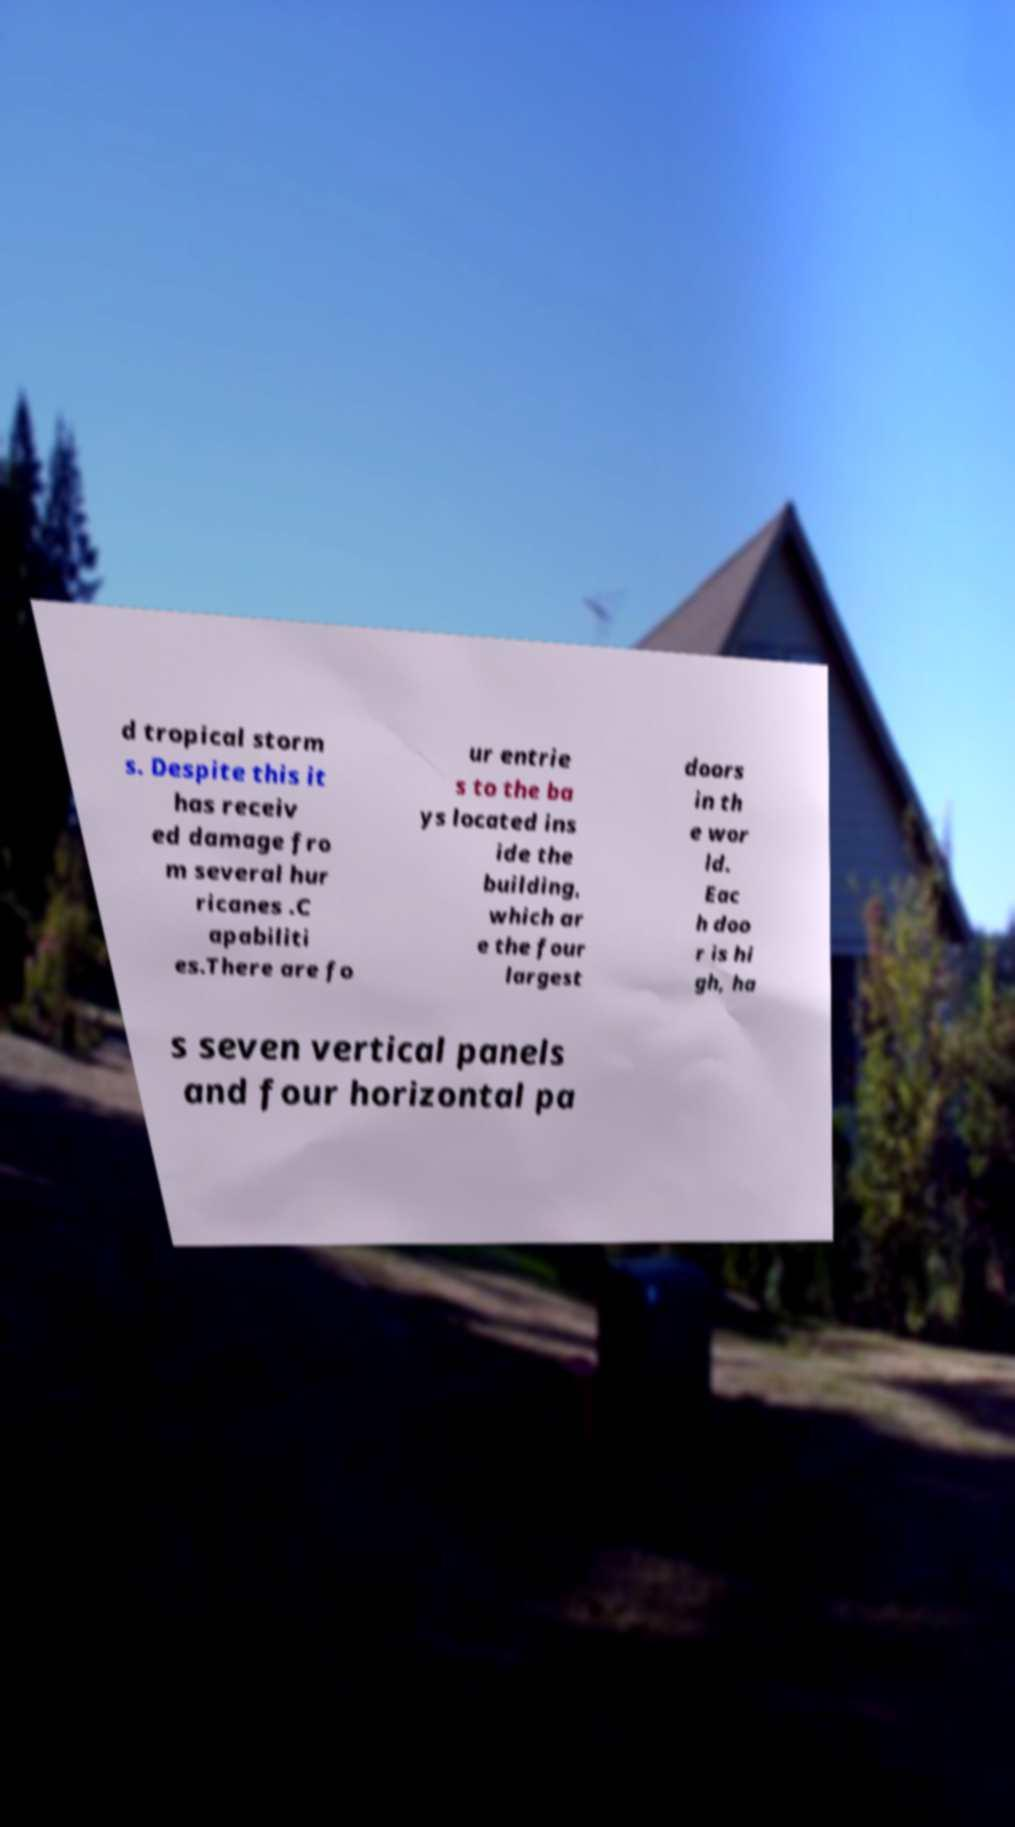Could you assist in decoding the text presented in this image and type it out clearly? d tropical storm s. Despite this it has receiv ed damage fro m several hur ricanes .C apabiliti es.There are fo ur entrie s to the ba ys located ins ide the building, which ar e the four largest doors in th e wor ld. Eac h doo r is hi gh, ha s seven vertical panels and four horizontal pa 